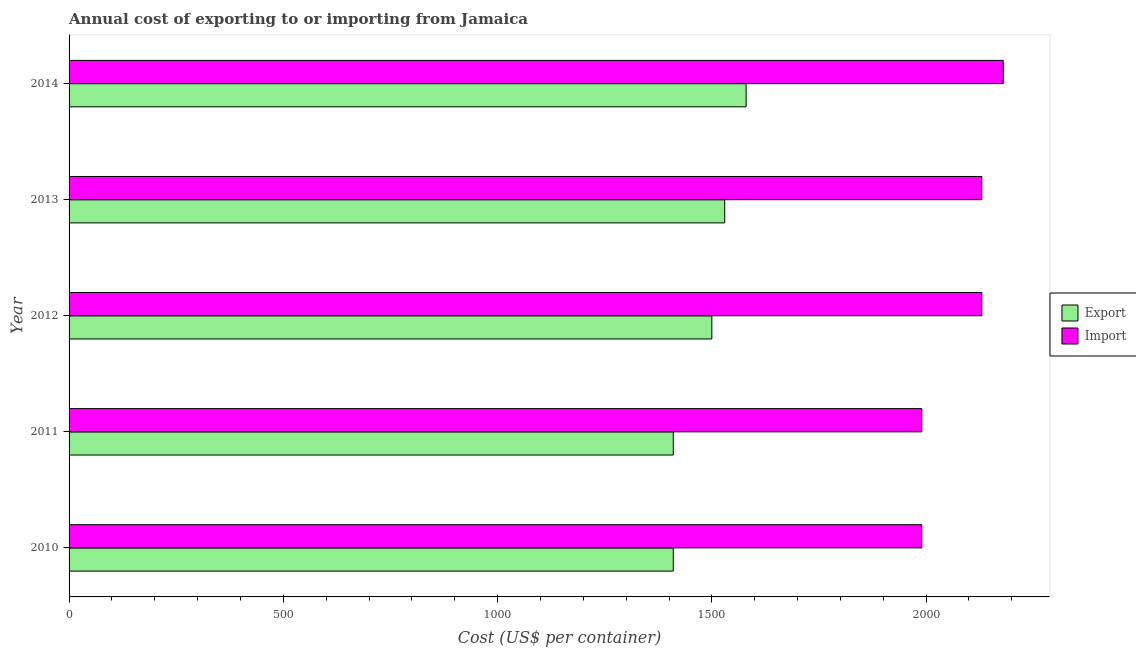How many groups of bars are there?
Offer a very short reply. 5. Are the number of bars per tick equal to the number of legend labels?
Provide a short and direct response. Yes. How many bars are there on the 4th tick from the top?
Offer a terse response. 2. How many bars are there on the 3rd tick from the bottom?
Provide a short and direct response. 2. In how many cases, is the number of bars for a given year not equal to the number of legend labels?
Offer a terse response. 0. What is the import cost in 2013?
Provide a succinct answer. 2130. Across all years, what is the maximum export cost?
Keep it short and to the point. 1580. Across all years, what is the minimum export cost?
Offer a very short reply. 1410. What is the total export cost in the graph?
Provide a succinct answer. 7430. What is the difference between the export cost in 2011 and that in 2013?
Your response must be concise. -120. What is the difference between the export cost in 2012 and the import cost in 2010?
Your answer should be compact. -490. What is the average import cost per year?
Your response must be concise. 2084. In the year 2011, what is the difference between the import cost and export cost?
Make the answer very short. 580. What is the ratio of the import cost in 2011 to that in 2012?
Offer a very short reply. 0.93. Is the difference between the import cost in 2011 and 2013 greater than the difference between the export cost in 2011 and 2013?
Your answer should be very brief. No. What is the difference between the highest and the lowest export cost?
Offer a terse response. 170. Is the sum of the export cost in 2012 and 2014 greater than the maximum import cost across all years?
Offer a very short reply. Yes. What does the 1st bar from the top in 2014 represents?
Offer a very short reply. Import. What does the 2nd bar from the bottom in 2013 represents?
Ensure brevity in your answer.  Import. How many bars are there?
Offer a very short reply. 10. Are all the bars in the graph horizontal?
Give a very brief answer. Yes. What is the difference between two consecutive major ticks on the X-axis?
Give a very brief answer. 500. Does the graph contain grids?
Offer a terse response. No. Where does the legend appear in the graph?
Make the answer very short. Center right. How are the legend labels stacked?
Ensure brevity in your answer.  Vertical. What is the title of the graph?
Your answer should be very brief. Annual cost of exporting to or importing from Jamaica. What is the label or title of the X-axis?
Keep it short and to the point. Cost (US$ per container). What is the Cost (US$ per container) in Export in 2010?
Your answer should be very brief. 1410. What is the Cost (US$ per container) in Import in 2010?
Your answer should be compact. 1990. What is the Cost (US$ per container) in Export in 2011?
Give a very brief answer. 1410. What is the Cost (US$ per container) in Import in 2011?
Ensure brevity in your answer.  1990. What is the Cost (US$ per container) in Export in 2012?
Offer a very short reply. 1500. What is the Cost (US$ per container) of Import in 2012?
Ensure brevity in your answer.  2130. What is the Cost (US$ per container) in Export in 2013?
Provide a short and direct response. 1530. What is the Cost (US$ per container) in Import in 2013?
Your answer should be very brief. 2130. What is the Cost (US$ per container) of Export in 2014?
Your response must be concise. 1580. What is the Cost (US$ per container) in Import in 2014?
Provide a succinct answer. 2180. Across all years, what is the maximum Cost (US$ per container) of Export?
Provide a short and direct response. 1580. Across all years, what is the maximum Cost (US$ per container) of Import?
Ensure brevity in your answer.  2180. Across all years, what is the minimum Cost (US$ per container) of Export?
Your answer should be compact. 1410. Across all years, what is the minimum Cost (US$ per container) in Import?
Offer a terse response. 1990. What is the total Cost (US$ per container) of Export in the graph?
Keep it short and to the point. 7430. What is the total Cost (US$ per container) in Import in the graph?
Provide a succinct answer. 1.04e+04. What is the difference between the Cost (US$ per container) of Export in 2010 and that in 2011?
Your response must be concise. 0. What is the difference between the Cost (US$ per container) in Export in 2010 and that in 2012?
Make the answer very short. -90. What is the difference between the Cost (US$ per container) in Import in 2010 and that in 2012?
Your answer should be compact. -140. What is the difference between the Cost (US$ per container) of Export in 2010 and that in 2013?
Offer a terse response. -120. What is the difference between the Cost (US$ per container) of Import in 2010 and that in 2013?
Offer a very short reply. -140. What is the difference between the Cost (US$ per container) in Export in 2010 and that in 2014?
Your answer should be compact. -170. What is the difference between the Cost (US$ per container) of Import in 2010 and that in 2014?
Keep it short and to the point. -190. What is the difference between the Cost (US$ per container) of Export in 2011 and that in 2012?
Your answer should be compact. -90. What is the difference between the Cost (US$ per container) in Import in 2011 and that in 2012?
Keep it short and to the point. -140. What is the difference between the Cost (US$ per container) of Export in 2011 and that in 2013?
Provide a short and direct response. -120. What is the difference between the Cost (US$ per container) of Import in 2011 and that in 2013?
Your response must be concise. -140. What is the difference between the Cost (US$ per container) of Export in 2011 and that in 2014?
Your answer should be very brief. -170. What is the difference between the Cost (US$ per container) of Import in 2011 and that in 2014?
Keep it short and to the point. -190. What is the difference between the Cost (US$ per container) of Export in 2012 and that in 2013?
Your answer should be very brief. -30. What is the difference between the Cost (US$ per container) in Export in 2012 and that in 2014?
Keep it short and to the point. -80. What is the difference between the Cost (US$ per container) in Import in 2012 and that in 2014?
Ensure brevity in your answer.  -50. What is the difference between the Cost (US$ per container) of Import in 2013 and that in 2014?
Your answer should be very brief. -50. What is the difference between the Cost (US$ per container) in Export in 2010 and the Cost (US$ per container) in Import in 2011?
Your answer should be very brief. -580. What is the difference between the Cost (US$ per container) of Export in 2010 and the Cost (US$ per container) of Import in 2012?
Provide a short and direct response. -720. What is the difference between the Cost (US$ per container) of Export in 2010 and the Cost (US$ per container) of Import in 2013?
Your answer should be very brief. -720. What is the difference between the Cost (US$ per container) of Export in 2010 and the Cost (US$ per container) of Import in 2014?
Provide a succinct answer. -770. What is the difference between the Cost (US$ per container) of Export in 2011 and the Cost (US$ per container) of Import in 2012?
Ensure brevity in your answer.  -720. What is the difference between the Cost (US$ per container) of Export in 2011 and the Cost (US$ per container) of Import in 2013?
Your response must be concise. -720. What is the difference between the Cost (US$ per container) of Export in 2011 and the Cost (US$ per container) of Import in 2014?
Keep it short and to the point. -770. What is the difference between the Cost (US$ per container) of Export in 2012 and the Cost (US$ per container) of Import in 2013?
Offer a terse response. -630. What is the difference between the Cost (US$ per container) in Export in 2012 and the Cost (US$ per container) in Import in 2014?
Make the answer very short. -680. What is the difference between the Cost (US$ per container) of Export in 2013 and the Cost (US$ per container) of Import in 2014?
Ensure brevity in your answer.  -650. What is the average Cost (US$ per container) of Export per year?
Your response must be concise. 1486. What is the average Cost (US$ per container) of Import per year?
Keep it short and to the point. 2084. In the year 2010, what is the difference between the Cost (US$ per container) of Export and Cost (US$ per container) of Import?
Provide a succinct answer. -580. In the year 2011, what is the difference between the Cost (US$ per container) in Export and Cost (US$ per container) in Import?
Ensure brevity in your answer.  -580. In the year 2012, what is the difference between the Cost (US$ per container) of Export and Cost (US$ per container) of Import?
Your response must be concise. -630. In the year 2013, what is the difference between the Cost (US$ per container) in Export and Cost (US$ per container) in Import?
Offer a very short reply. -600. In the year 2014, what is the difference between the Cost (US$ per container) in Export and Cost (US$ per container) in Import?
Provide a short and direct response. -600. What is the ratio of the Cost (US$ per container) of Export in 2010 to that in 2012?
Provide a succinct answer. 0.94. What is the ratio of the Cost (US$ per container) in Import in 2010 to that in 2012?
Your answer should be compact. 0.93. What is the ratio of the Cost (US$ per container) of Export in 2010 to that in 2013?
Offer a terse response. 0.92. What is the ratio of the Cost (US$ per container) in Import in 2010 to that in 2013?
Your answer should be very brief. 0.93. What is the ratio of the Cost (US$ per container) of Export in 2010 to that in 2014?
Offer a very short reply. 0.89. What is the ratio of the Cost (US$ per container) of Import in 2010 to that in 2014?
Make the answer very short. 0.91. What is the ratio of the Cost (US$ per container) in Export in 2011 to that in 2012?
Offer a very short reply. 0.94. What is the ratio of the Cost (US$ per container) in Import in 2011 to that in 2012?
Your answer should be compact. 0.93. What is the ratio of the Cost (US$ per container) of Export in 2011 to that in 2013?
Make the answer very short. 0.92. What is the ratio of the Cost (US$ per container) of Import in 2011 to that in 2013?
Keep it short and to the point. 0.93. What is the ratio of the Cost (US$ per container) of Export in 2011 to that in 2014?
Provide a short and direct response. 0.89. What is the ratio of the Cost (US$ per container) in Import in 2011 to that in 2014?
Provide a short and direct response. 0.91. What is the ratio of the Cost (US$ per container) of Export in 2012 to that in 2013?
Give a very brief answer. 0.98. What is the ratio of the Cost (US$ per container) of Export in 2012 to that in 2014?
Provide a short and direct response. 0.95. What is the ratio of the Cost (US$ per container) in Import in 2012 to that in 2014?
Your response must be concise. 0.98. What is the ratio of the Cost (US$ per container) in Export in 2013 to that in 2014?
Offer a terse response. 0.97. What is the ratio of the Cost (US$ per container) of Import in 2013 to that in 2014?
Offer a terse response. 0.98. What is the difference between the highest and the second highest Cost (US$ per container) in Import?
Make the answer very short. 50. What is the difference between the highest and the lowest Cost (US$ per container) of Export?
Offer a terse response. 170. What is the difference between the highest and the lowest Cost (US$ per container) of Import?
Your response must be concise. 190. 